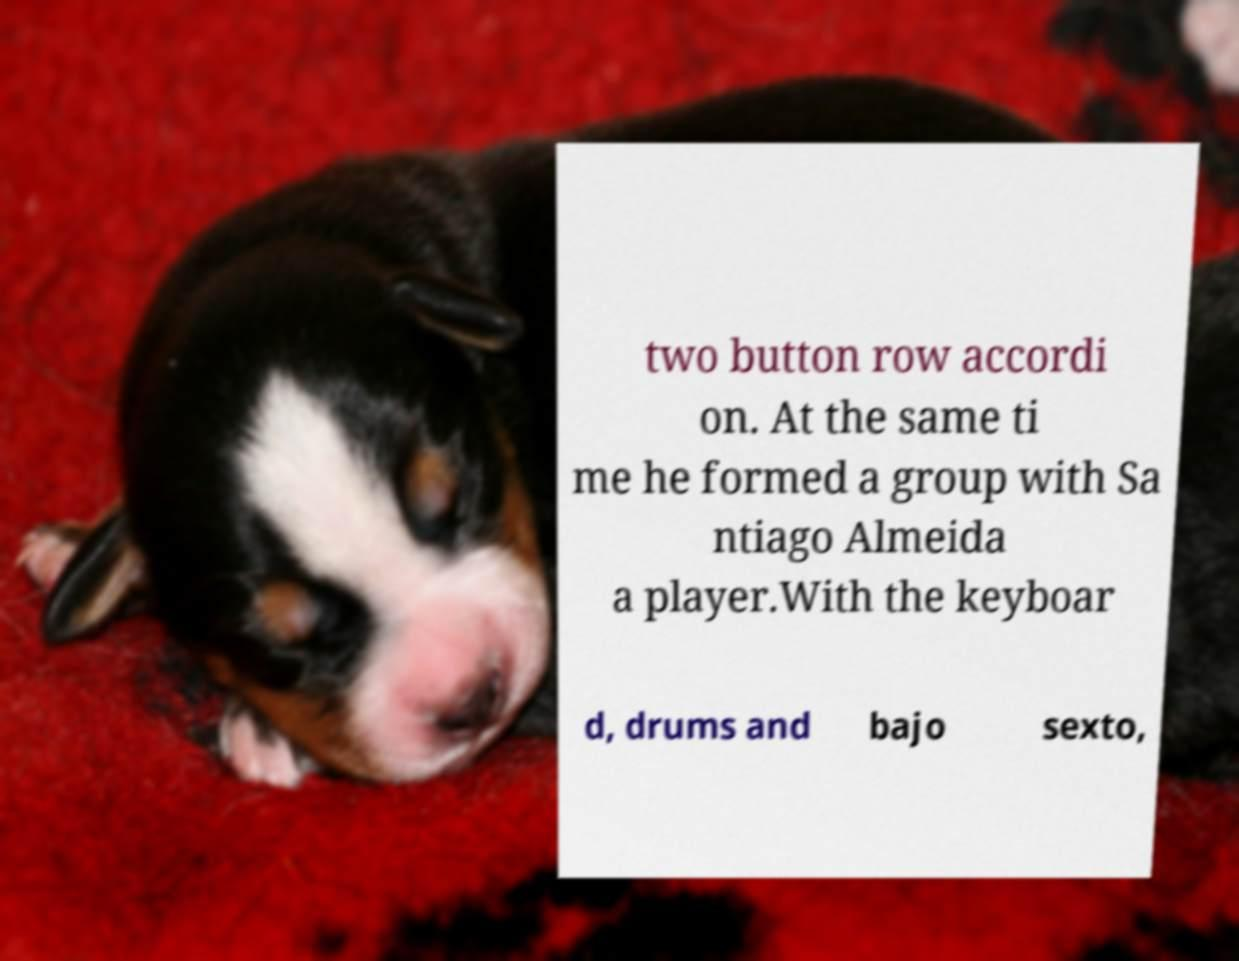Could you assist in decoding the text presented in this image and type it out clearly? two button row accordi on. At the same ti me he formed a group with Sa ntiago Almeida a player.With the keyboar d, drums and bajo sexto, 